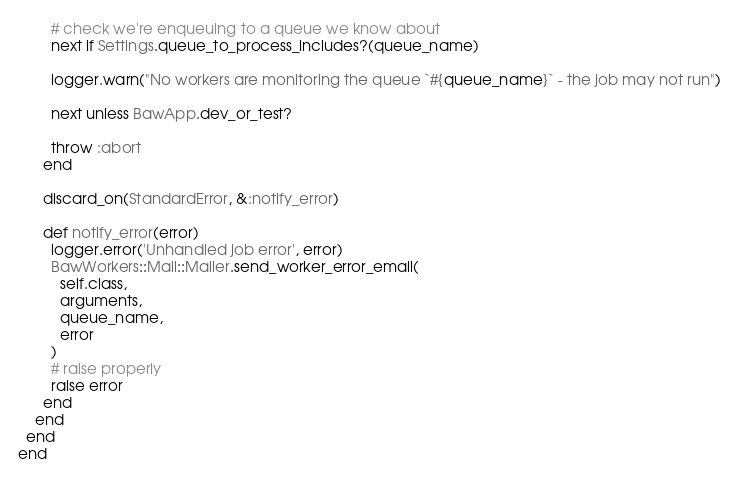Convert code to text. <code><loc_0><loc_0><loc_500><loc_500><_Ruby_>        # check we're enqueuing to a queue we know about
        next if Settings.queue_to_process_includes?(queue_name)

        logger.warn("No workers are monitoring the queue `#{queue_name}` - the job may not run")

        next unless BawApp.dev_or_test?

        throw :abort
      end

      discard_on(StandardError, &:notify_error)

      def notify_error(error)
        logger.error('Unhandled job error', error)
        BawWorkers::Mail::Mailer.send_worker_error_email(
          self.class,
          arguments,
          queue_name,
          error
        )
        # raise properly
        raise error
      end
    end
  end
end
</code> 